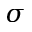Convert formula to latex. <formula><loc_0><loc_0><loc_500><loc_500>\sigma</formula> 